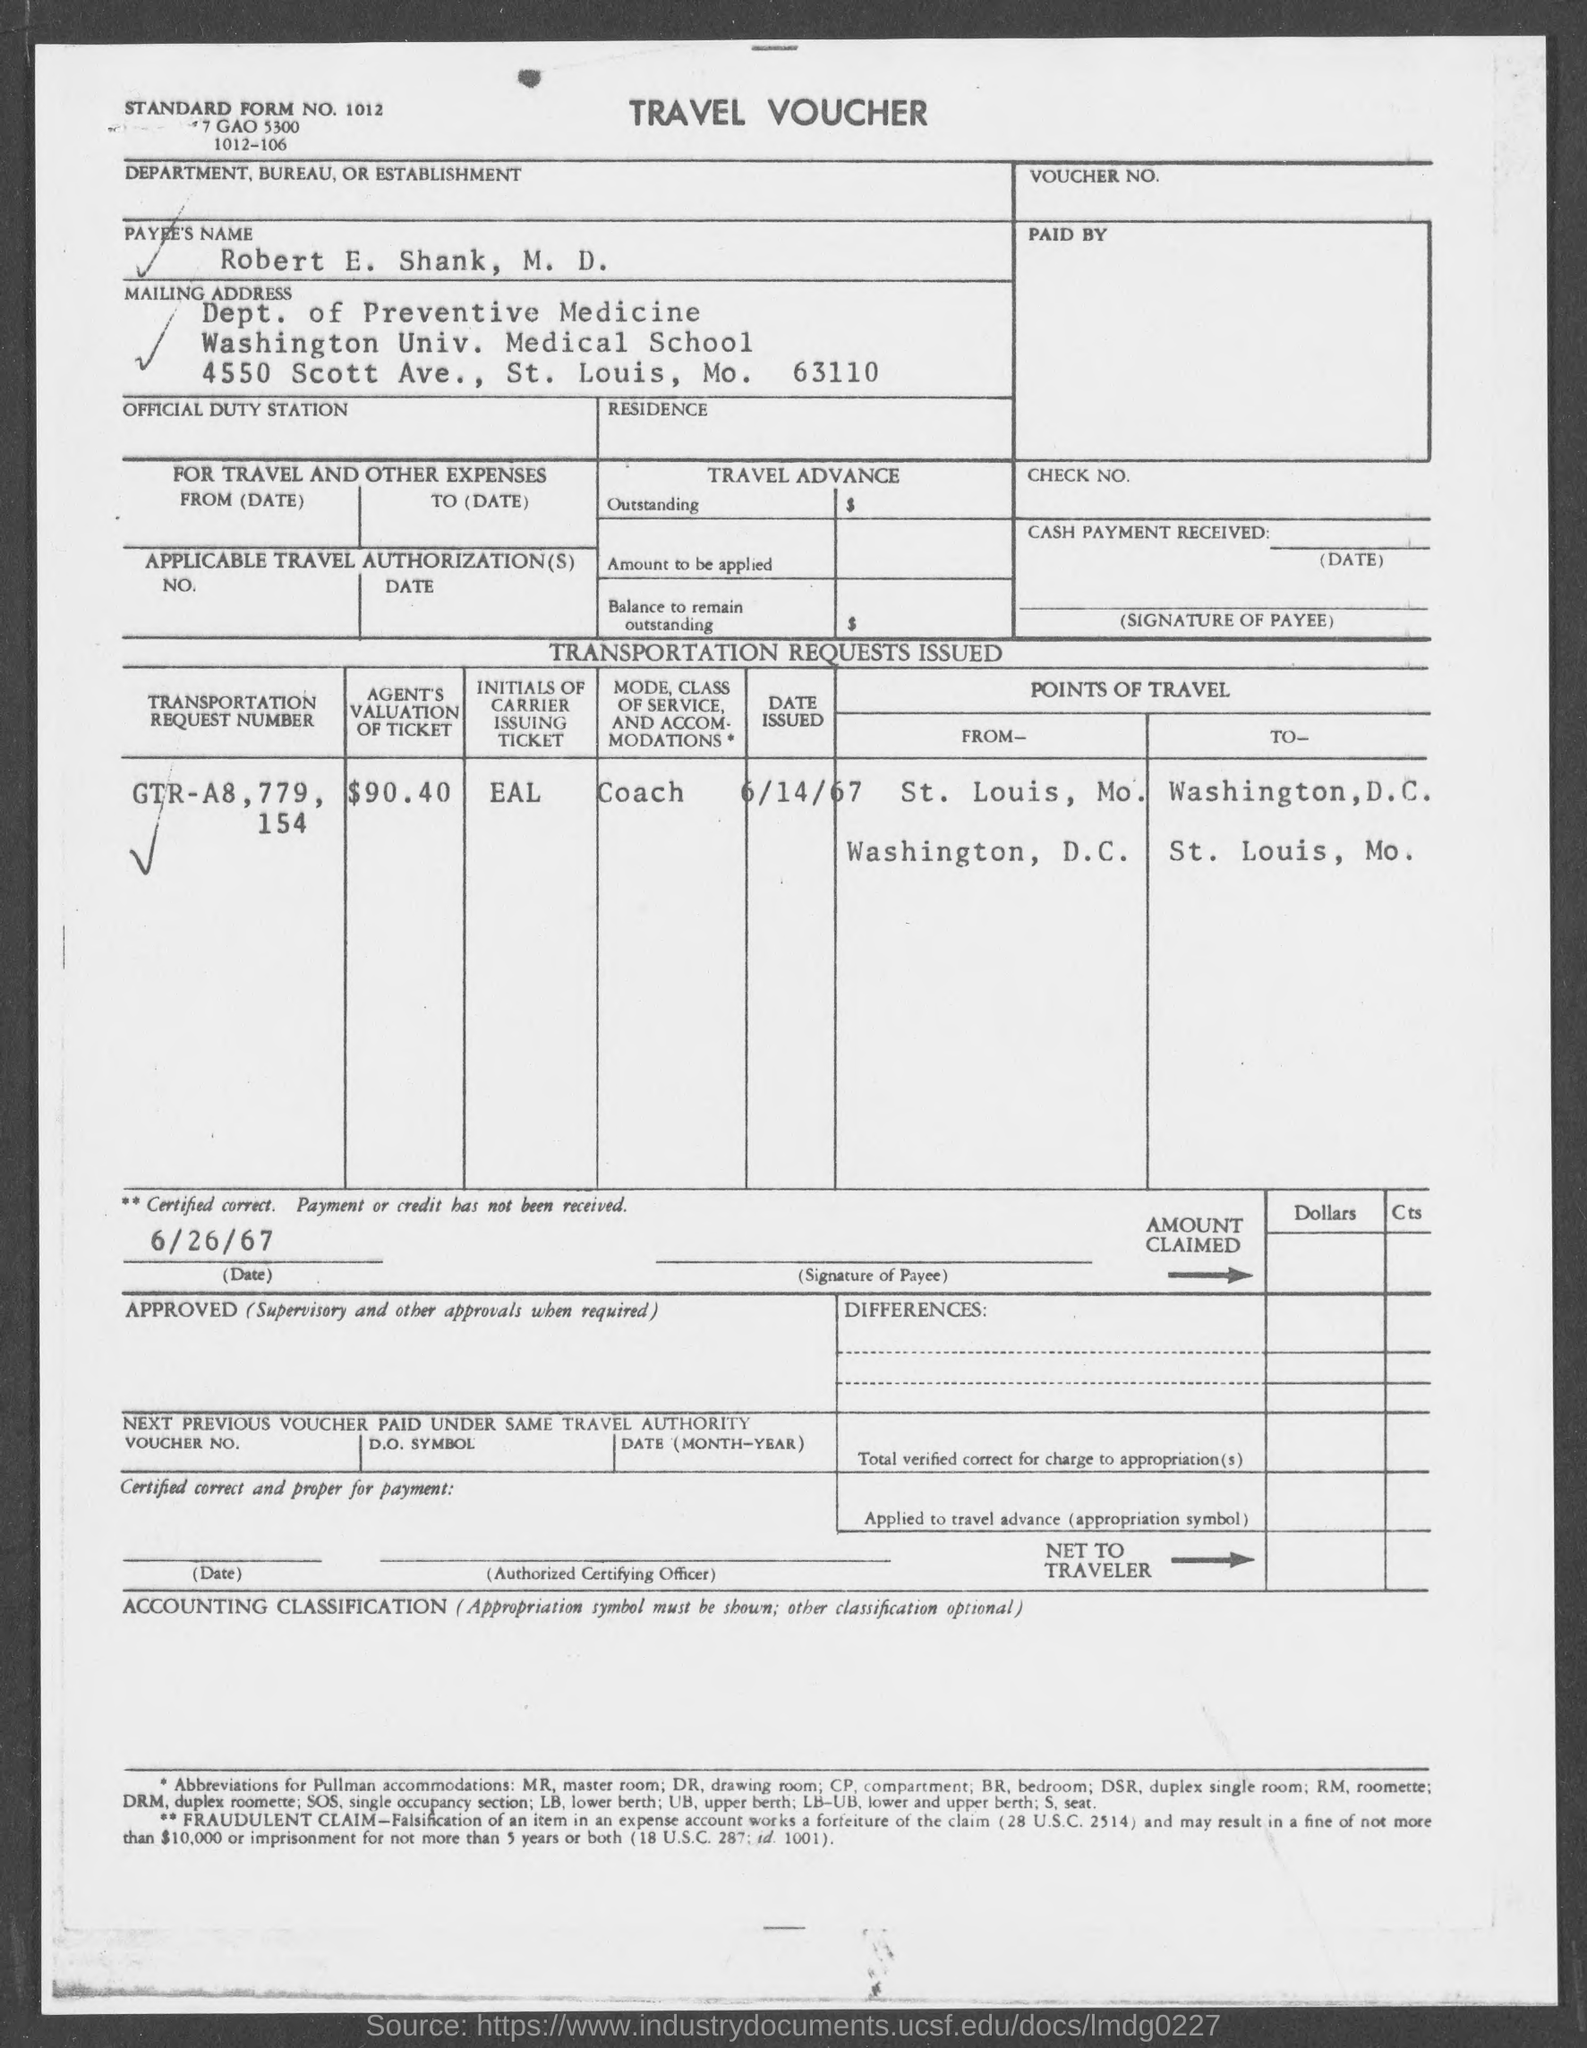Mention a couple of crucial points in this snapshot. The payee's name is Robert E. Shank. The valuation of the ticket by the agents is $90.40. The mode of class of service and accommodations is coach. 